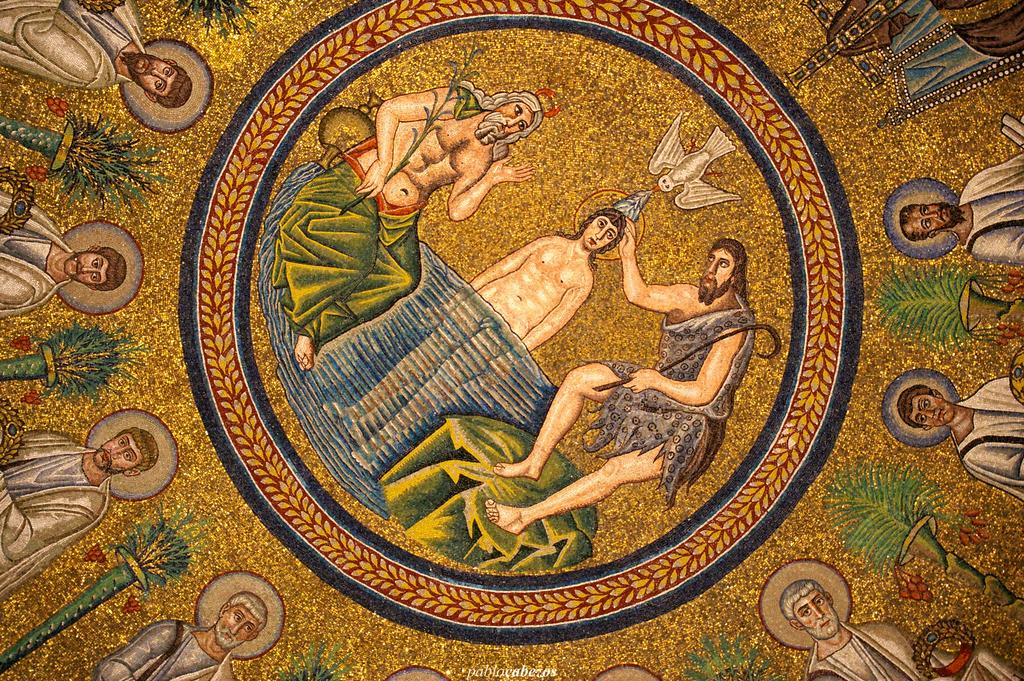What type of artwork is depicted in the image? The image is a painting. Can you describe the subjects in the painting? There are persons and a bird in the painting. What type of natural environment is present in the painting? There is grass in the painting. What man-made structures can be seen in the painting? There are poles in the painting. Are there any other objects or elements in the painting? Yes, there are other objects in the painting. What is the price of the van in the painting? There is no van present in the painting, so it is not possible to determine its price. 